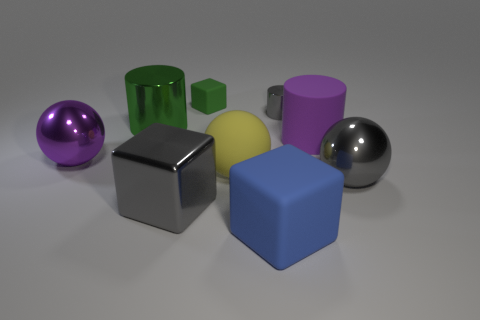What material is the cylinder that is the same size as the green metallic thing?
Your response must be concise. Rubber. Is the number of large rubber cylinders greater than the number of tiny red objects?
Provide a short and direct response. Yes. Does the small gray thing have the same material as the big green thing?
Keep it short and to the point. Yes. There is a green thing that is made of the same material as the gray block; what shape is it?
Keep it short and to the point. Cylinder. Are there fewer big purple spheres than big things?
Provide a succinct answer. Yes. What material is the cube that is both to the right of the shiny block and in front of the tiny matte cube?
Offer a very short reply. Rubber. There is a metallic cylinder that is on the left side of the cube behind the large purple object that is to the right of the big green thing; what size is it?
Ensure brevity in your answer.  Large. There is a tiny rubber object; is it the same shape as the purple thing that is left of the large yellow rubber sphere?
Your response must be concise. No. What number of objects are on the right side of the big metal cylinder and in front of the purple rubber object?
Your answer should be compact. 4. How many gray things are either small matte cylinders or things?
Offer a terse response. 3. 